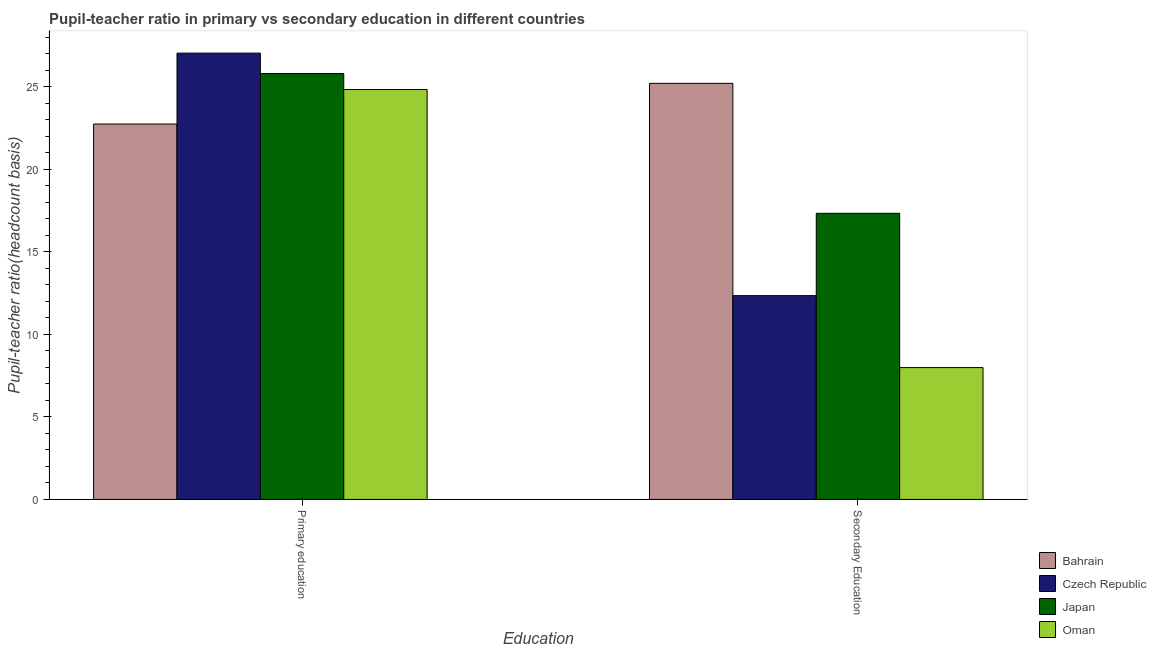How many groups of bars are there?
Give a very brief answer. 2. Are the number of bars per tick equal to the number of legend labels?
Give a very brief answer. Yes. How many bars are there on the 1st tick from the left?
Provide a short and direct response. 4. What is the label of the 2nd group of bars from the left?
Your answer should be very brief. Secondary Education. What is the pupil teacher ratio on secondary education in Japan?
Offer a terse response. 17.33. Across all countries, what is the maximum pupil teacher ratio on secondary education?
Provide a succinct answer. 25.2. Across all countries, what is the minimum pupil-teacher ratio in primary education?
Your answer should be compact. 22.73. In which country was the pupil teacher ratio on secondary education maximum?
Make the answer very short. Bahrain. In which country was the pupil teacher ratio on secondary education minimum?
Your answer should be very brief. Oman. What is the total pupil-teacher ratio in primary education in the graph?
Provide a short and direct response. 100.38. What is the difference between the pupil teacher ratio on secondary education in Czech Republic and that in Bahrain?
Your answer should be compact. -12.86. What is the difference between the pupil teacher ratio on secondary education in Czech Republic and the pupil-teacher ratio in primary education in Oman?
Offer a very short reply. -12.48. What is the average pupil teacher ratio on secondary education per country?
Ensure brevity in your answer.  15.71. What is the difference between the pupil teacher ratio on secondary education and pupil-teacher ratio in primary education in Japan?
Offer a terse response. -8.46. What is the ratio of the pupil-teacher ratio in primary education in Japan to that in Oman?
Make the answer very short. 1.04. Is the pupil teacher ratio on secondary education in Oman less than that in Bahrain?
Offer a terse response. Yes. In how many countries, is the pupil-teacher ratio in primary education greater than the average pupil-teacher ratio in primary education taken over all countries?
Provide a succinct answer. 2. What does the 1st bar from the left in Secondary Education represents?
Offer a terse response. Bahrain. What does the 1st bar from the right in Secondary Education represents?
Make the answer very short. Oman. Are all the bars in the graph horizontal?
Provide a short and direct response. No. Are the values on the major ticks of Y-axis written in scientific E-notation?
Keep it short and to the point. No. Does the graph contain any zero values?
Offer a very short reply. No. How many legend labels are there?
Give a very brief answer. 4. What is the title of the graph?
Provide a short and direct response. Pupil-teacher ratio in primary vs secondary education in different countries. What is the label or title of the X-axis?
Offer a terse response. Education. What is the label or title of the Y-axis?
Provide a succinct answer. Pupil-teacher ratio(headcount basis). What is the Pupil-teacher ratio(headcount basis) in Bahrain in Primary education?
Provide a succinct answer. 22.73. What is the Pupil-teacher ratio(headcount basis) in Czech Republic in Primary education?
Offer a very short reply. 27.03. What is the Pupil-teacher ratio(headcount basis) in Japan in Primary education?
Make the answer very short. 25.79. What is the Pupil-teacher ratio(headcount basis) in Oman in Primary education?
Offer a very short reply. 24.82. What is the Pupil-teacher ratio(headcount basis) in Bahrain in Secondary Education?
Your answer should be very brief. 25.2. What is the Pupil-teacher ratio(headcount basis) in Czech Republic in Secondary Education?
Offer a very short reply. 12.34. What is the Pupil-teacher ratio(headcount basis) in Japan in Secondary Education?
Your response must be concise. 17.33. What is the Pupil-teacher ratio(headcount basis) of Oman in Secondary Education?
Your answer should be very brief. 7.98. Across all Education, what is the maximum Pupil-teacher ratio(headcount basis) in Bahrain?
Your answer should be very brief. 25.2. Across all Education, what is the maximum Pupil-teacher ratio(headcount basis) of Czech Republic?
Your response must be concise. 27.03. Across all Education, what is the maximum Pupil-teacher ratio(headcount basis) of Japan?
Keep it short and to the point. 25.79. Across all Education, what is the maximum Pupil-teacher ratio(headcount basis) of Oman?
Offer a very short reply. 24.82. Across all Education, what is the minimum Pupil-teacher ratio(headcount basis) in Bahrain?
Give a very brief answer. 22.73. Across all Education, what is the minimum Pupil-teacher ratio(headcount basis) in Czech Republic?
Keep it short and to the point. 12.34. Across all Education, what is the minimum Pupil-teacher ratio(headcount basis) in Japan?
Your answer should be very brief. 17.33. Across all Education, what is the minimum Pupil-teacher ratio(headcount basis) of Oman?
Offer a terse response. 7.98. What is the total Pupil-teacher ratio(headcount basis) of Bahrain in the graph?
Your answer should be compact. 47.93. What is the total Pupil-teacher ratio(headcount basis) of Czech Republic in the graph?
Keep it short and to the point. 39.37. What is the total Pupil-teacher ratio(headcount basis) of Japan in the graph?
Provide a short and direct response. 43.12. What is the total Pupil-teacher ratio(headcount basis) in Oman in the graph?
Keep it short and to the point. 32.81. What is the difference between the Pupil-teacher ratio(headcount basis) in Bahrain in Primary education and that in Secondary Education?
Give a very brief answer. -2.47. What is the difference between the Pupil-teacher ratio(headcount basis) of Czech Republic in Primary education and that in Secondary Education?
Offer a terse response. 14.69. What is the difference between the Pupil-teacher ratio(headcount basis) of Japan in Primary education and that in Secondary Education?
Offer a terse response. 8.46. What is the difference between the Pupil-teacher ratio(headcount basis) in Oman in Primary education and that in Secondary Education?
Offer a terse response. 16.84. What is the difference between the Pupil-teacher ratio(headcount basis) of Bahrain in Primary education and the Pupil-teacher ratio(headcount basis) of Czech Republic in Secondary Education?
Keep it short and to the point. 10.39. What is the difference between the Pupil-teacher ratio(headcount basis) of Bahrain in Primary education and the Pupil-teacher ratio(headcount basis) of Japan in Secondary Education?
Give a very brief answer. 5.41. What is the difference between the Pupil-teacher ratio(headcount basis) of Bahrain in Primary education and the Pupil-teacher ratio(headcount basis) of Oman in Secondary Education?
Your answer should be very brief. 14.75. What is the difference between the Pupil-teacher ratio(headcount basis) in Czech Republic in Primary education and the Pupil-teacher ratio(headcount basis) in Japan in Secondary Education?
Provide a succinct answer. 9.7. What is the difference between the Pupil-teacher ratio(headcount basis) in Czech Republic in Primary education and the Pupil-teacher ratio(headcount basis) in Oman in Secondary Education?
Your response must be concise. 19.04. What is the difference between the Pupil-teacher ratio(headcount basis) of Japan in Primary education and the Pupil-teacher ratio(headcount basis) of Oman in Secondary Education?
Your response must be concise. 17.81. What is the average Pupil-teacher ratio(headcount basis) of Bahrain per Education?
Provide a succinct answer. 23.97. What is the average Pupil-teacher ratio(headcount basis) of Czech Republic per Education?
Your answer should be very brief. 19.68. What is the average Pupil-teacher ratio(headcount basis) in Japan per Education?
Provide a succinct answer. 21.56. What is the average Pupil-teacher ratio(headcount basis) of Oman per Education?
Give a very brief answer. 16.4. What is the difference between the Pupil-teacher ratio(headcount basis) in Bahrain and Pupil-teacher ratio(headcount basis) in Czech Republic in Primary education?
Ensure brevity in your answer.  -4.29. What is the difference between the Pupil-teacher ratio(headcount basis) of Bahrain and Pupil-teacher ratio(headcount basis) of Japan in Primary education?
Ensure brevity in your answer.  -3.06. What is the difference between the Pupil-teacher ratio(headcount basis) in Bahrain and Pupil-teacher ratio(headcount basis) in Oman in Primary education?
Provide a succinct answer. -2.09. What is the difference between the Pupil-teacher ratio(headcount basis) in Czech Republic and Pupil-teacher ratio(headcount basis) in Japan in Primary education?
Make the answer very short. 1.24. What is the difference between the Pupil-teacher ratio(headcount basis) of Czech Republic and Pupil-teacher ratio(headcount basis) of Oman in Primary education?
Make the answer very short. 2.2. What is the difference between the Pupil-teacher ratio(headcount basis) of Japan and Pupil-teacher ratio(headcount basis) of Oman in Primary education?
Make the answer very short. 0.97. What is the difference between the Pupil-teacher ratio(headcount basis) of Bahrain and Pupil-teacher ratio(headcount basis) of Czech Republic in Secondary Education?
Ensure brevity in your answer.  12.86. What is the difference between the Pupil-teacher ratio(headcount basis) of Bahrain and Pupil-teacher ratio(headcount basis) of Japan in Secondary Education?
Provide a short and direct response. 7.87. What is the difference between the Pupil-teacher ratio(headcount basis) in Bahrain and Pupil-teacher ratio(headcount basis) in Oman in Secondary Education?
Give a very brief answer. 17.21. What is the difference between the Pupil-teacher ratio(headcount basis) in Czech Republic and Pupil-teacher ratio(headcount basis) in Japan in Secondary Education?
Provide a short and direct response. -4.99. What is the difference between the Pupil-teacher ratio(headcount basis) in Czech Republic and Pupil-teacher ratio(headcount basis) in Oman in Secondary Education?
Your answer should be compact. 4.36. What is the difference between the Pupil-teacher ratio(headcount basis) of Japan and Pupil-teacher ratio(headcount basis) of Oman in Secondary Education?
Your answer should be very brief. 9.34. What is the ratio of the Pupil-teacher ratio(headcount basis) in Bahrain in Primary education to that in Secondary Education?
Your answer should be very brief. 0.9. What is the ratio of the Pupil-teacher ratio(headcount basis) of Czech Republic in Primary education to that in Secondary Education?
Keep it short and to the point. 2.19. What is the ratio of the Pupil-teacher ratio(headcount basis) of Japan in Primary education to that in Secondary Education?
Make the answer very short. 1.49. What is the ratio of the Pupil-teacher ratio(headcount basis) in Oman in Primary education to that in Secondary Education?
Provide a succinct answer. 3.11. What is the difference between the highest and the second highest Pupil-teacher ratio(headcount basis) in Bahrain?
Give a very brief answer. 2.47. What is the difference between the highest and the second highest Pupil-teacher ratio(headcount basis) of Czech Republic?
Keep it short and to the point. 14.69. What is the difference between the highest and the second highest Pupil-teacher ratio(headcount basis) of Japan?
Make the answer very short. 8.46. What is the difference between the highest and the second highest Pupil-teacher ratio(headcount basis) in Oman?
Your answer should be very brief. 16.84. What is the difference between the highest and the lowest Pupil-teacher ratio(headcount basis) of Bahrain?
Give a very brief answer. 2.47. What is the difference between the highest and the lowest Pupil-teacher ratio(headcount basis) of Czech Republic?
Your response must be concise. 14.69. What is the difference between the highest and the lowest Pupil-teacher ratio(headcount basis) of Japan?
Give a very brief answer. 8.46. What is the difference between the highest and the lowest Pupil-teacher ratio(headcount basis) of Oman?
Keep it short and to the point. 16.84. 